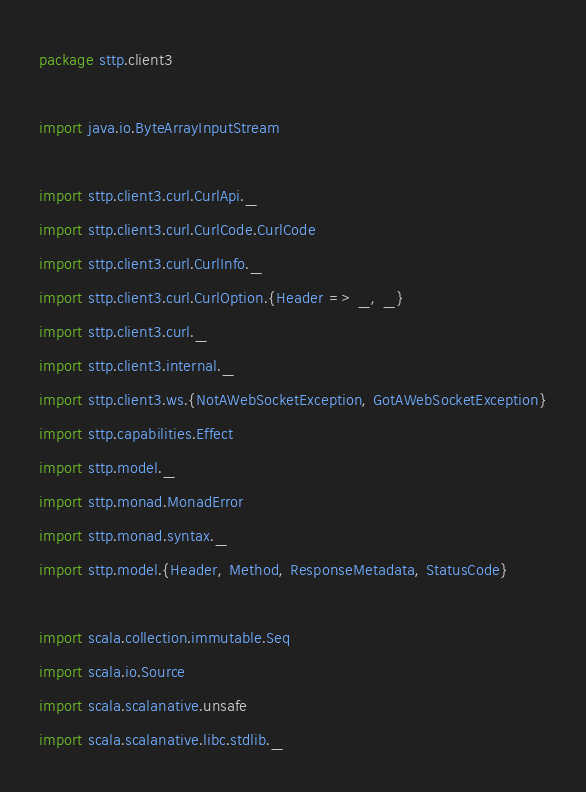<code> <loc_0><loc_0><loc_500><loc_500><_Scala_>package sttp.client3

import java.io.ByteArrayInputStream

import sttp.client3.curl.CurlApi._
import sttp.client3.curl.CurlCode.CurlCode
import sttp.client3.curl.CurlInfo._
import sttp.client3.curl.CurlOption.{Header => _, _}
import sttp.client3.curl._
import sttp.client3.internal._
import sttp.client3.ws.{NotAWebSocketException, GotAWebSocketException}
import sttp.capabilities.Effect
import sttp.model._
import sttp.monad.MonadError
import sttp.monad.syntax._
import sttp.model.{Header, Method, ResponseMetadata, StatusCode}

import scala.collection.immutable.Seq
import scala.io.Source
import scala.scalanative.unsafe
import scala.scalanative.libc.stdlib._</code> 